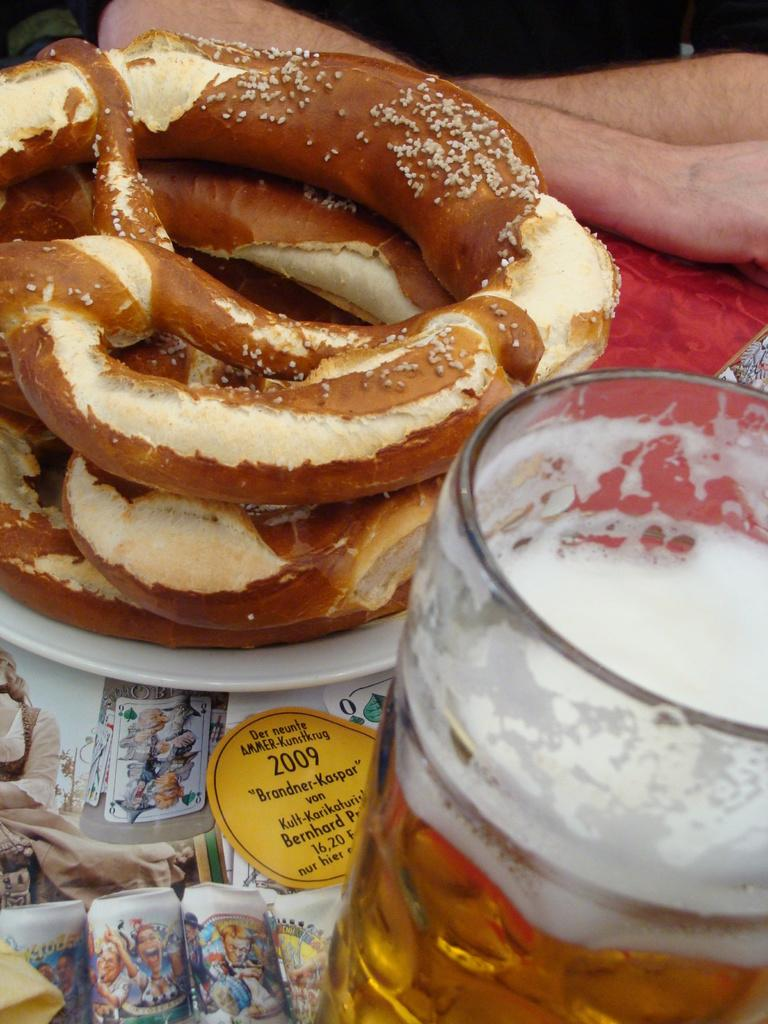What is contained in the glass that is visible in the image? There is a drink in the glass with a drink in the image. What else can be seen in the image besides the glass? There is food in the image. Can you describe anything in the background of the image? Human legs are visible in the background of the image. What type of print can be seen on the stranger's shirt in the image? There is no stranger present in the image, so it is not possible to determine the print on their shirt. 